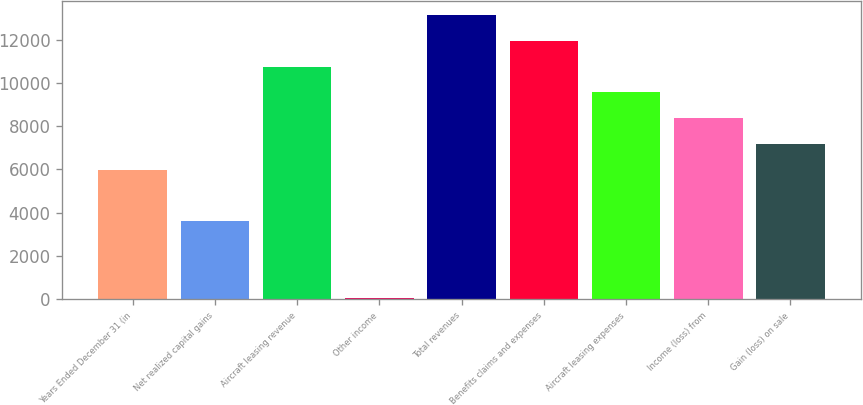Convert chart. <chart><loc_0><loc_0><loc_500><loc_500><bar_chart><fcel>Years Ended December 31 (in<fcel>Net realized capital gains<fcel>Aircraft leasing revenue<fcel>Other income<fcel>Total revenues<fcel>Benefits claims and expenses<fcel>Aircraft leasing expenses<fcel>Income (loss) from<fcel>Gain (loss) on sale<nl><fcel>5993<fcel>3615<fcel>10749<fcel>48<fcel>13127<fcel>11938<fcel>9560<fcel>8371<fcel>7182<nl></chart> 